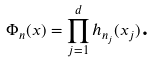Convert formula to latex. <formula><loc_0><loc_0><loc_500><loc_500>\Phi _ { n } ( x ) = \prod _ { j = 1 } ^ { d } h _ { n _ { j } } ( x _ { j } ) \text {.}</formula> 